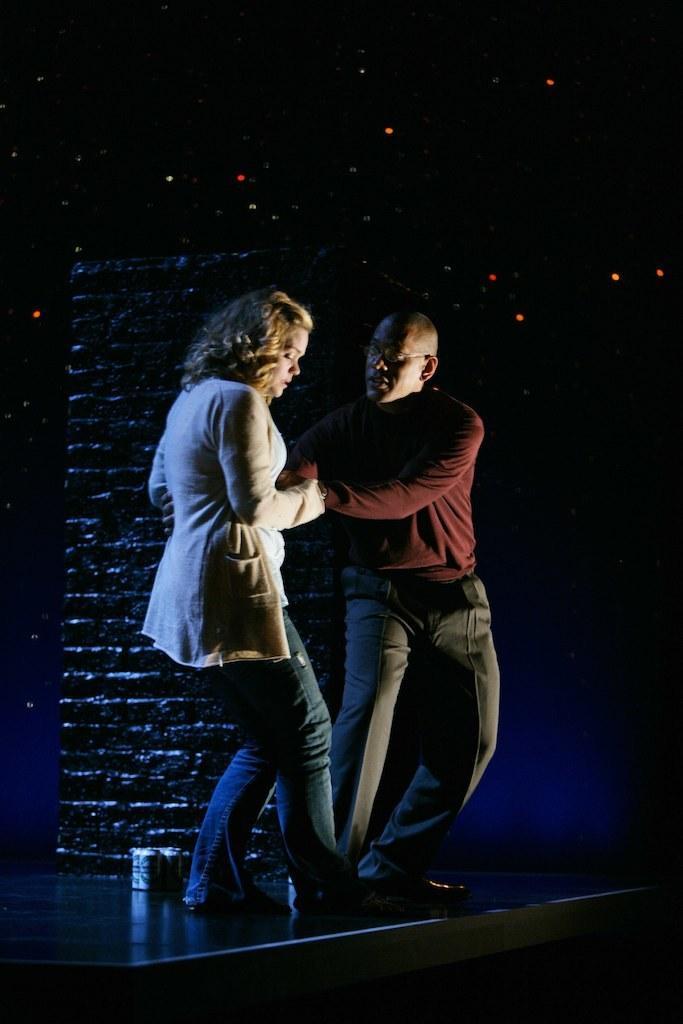Can you describe this image briefly? In this image I can see a woman is pulling the man, she wore coat, trouser. Beside him there is man, he wore shirt, trouser, shoes and spectacles. Behind them it looks like a building. 